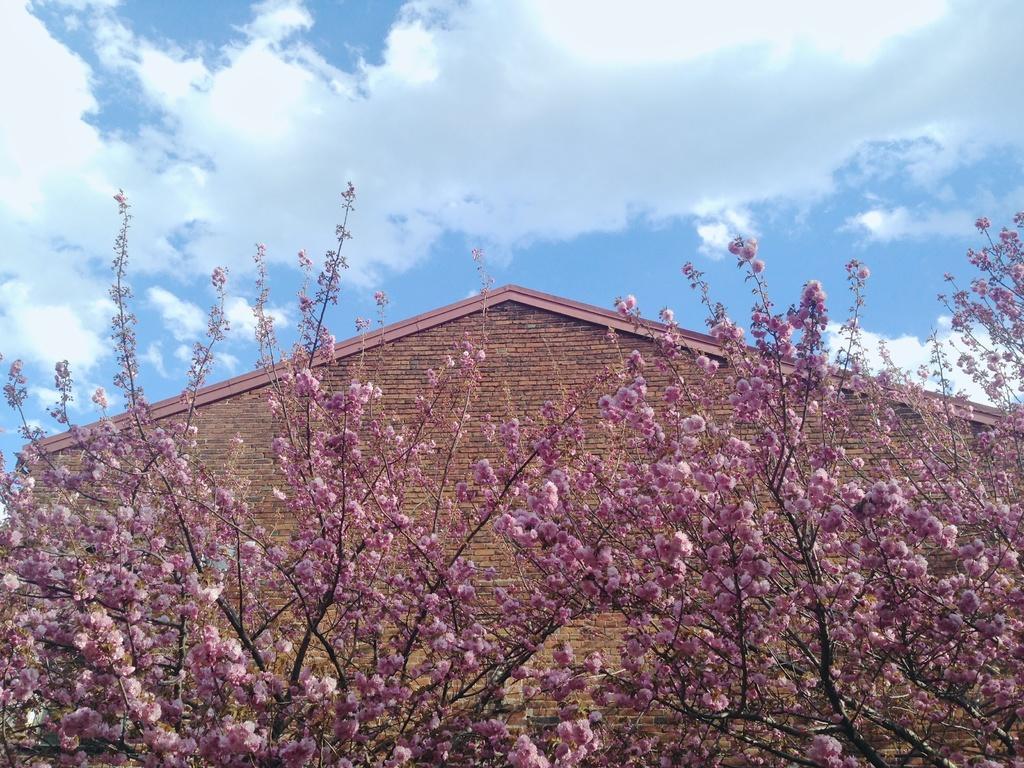Describe this image in one or two sentences. There are pink flowers on the trees. In the back there is a building. Also there is sky with clouds. 